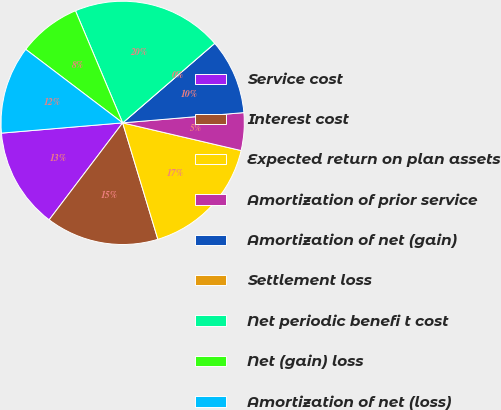<chart> <loc_0><loc_0><loc_500><loc_500><pie_chart><fcel>Service cost<fcel>Interest cost<fcel>Expected return on plan assets<fcel>Amortization of prior service<fcel>Amortization of net (gain)<fcel>Settlement loss<fcel>Net periodic benefi t cost<fcel>Net (gain) loss<fcel>Amortization of net (loss)<nl><fcel>13.33%<fcel>15.0%<fcel>16.67%<fcel>5.0%<fcel>10.0%<fcel>0.0%<fcel>20.0%<fcel>8.33%<fcel>11.67%<nl></chart> 